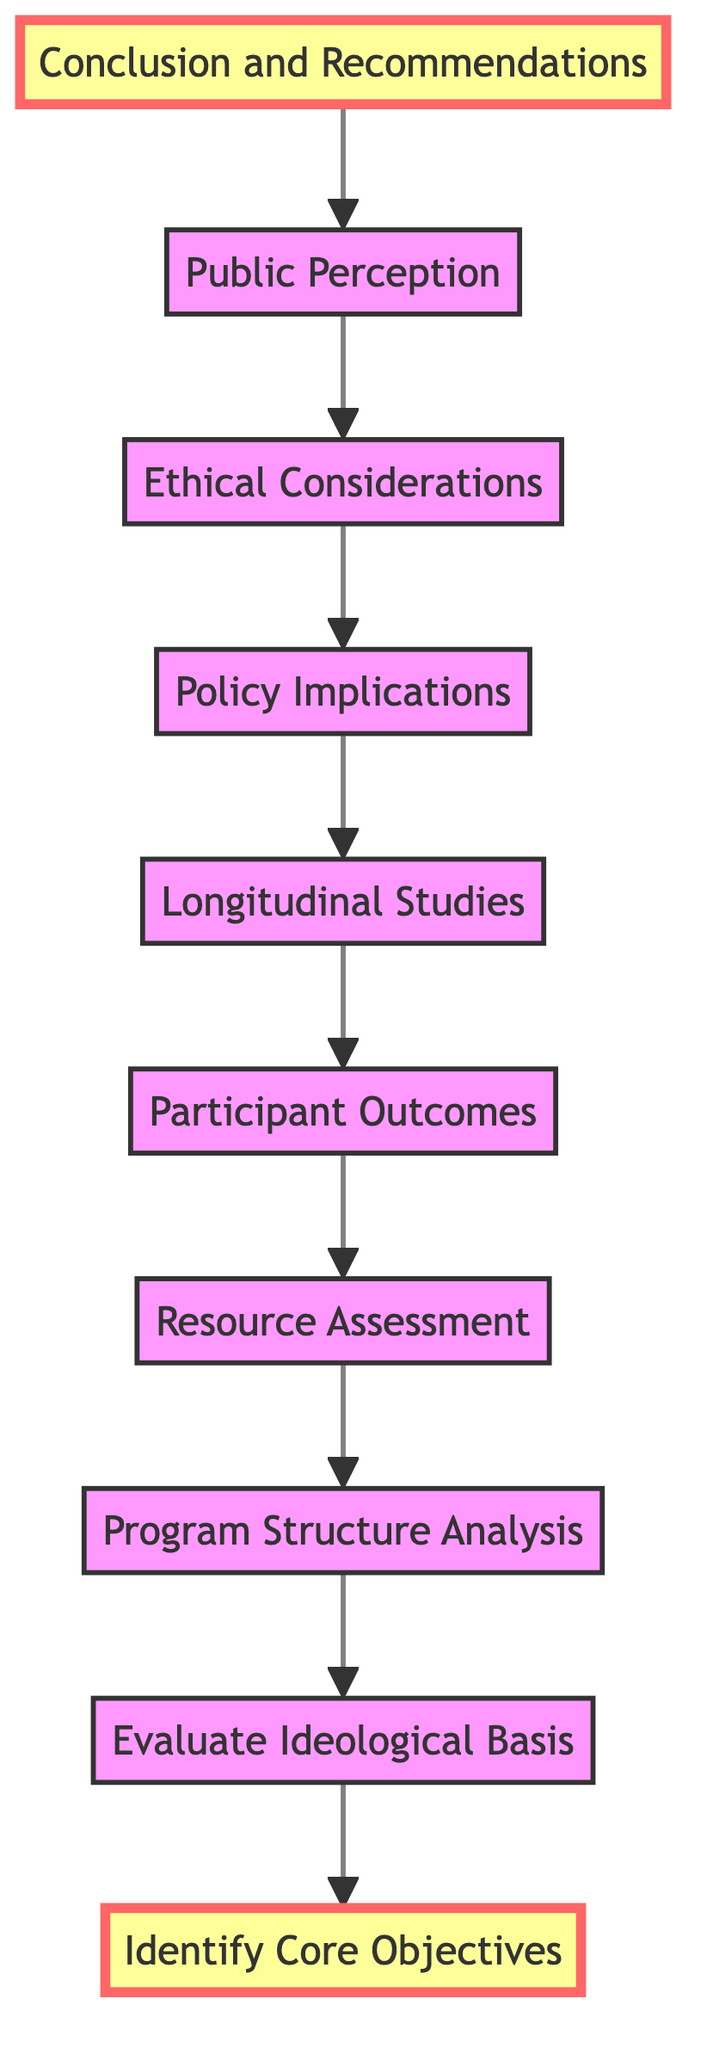What is the first step in the diagram? The first step in the diagram is to identify the core objectives, as it is the bottom-most node in the flow.
Answer: Identify Core Objectives How many nodes are present in the diagram? There are a total of ten nodes represented in the flowchart, each corresponding to a distinct step in the analysis process.
Answer: 10 What is the last step in the flowchart? The last step in the flowchart is to summarize findings and offer recommendations, which is indicated at the top of the diagram.
Answer: Conclusion and Recommendations Which two nodes are directly connected? The nodes "Participant Outcomes" and "Longitudinal Studies" are directly connected, indicating a flow of information from one to the other.
Answer: Participant Outcomes and Longitudinal Studies What type of program is celebrated in the Program Structure Analysis? The Program Structure Analysis focuses on faith-based programs, specifically referring to initiatives like Celebrate Recovery as compared to secular programs.
Answer: Celebrate Recovery Which step comes before the Policy Implications step? The step that comes before the Policy Implications is called Ethical Considerations, as seen in the upward flow of the diagram.
Answer: Ethical Considerations What are the main types of programs compared in this analysis? The main types of programs compared are faith-based programs and secular alternatives, as highlighted in the Evaluation Ideological Basis step.
Answer: Faith-based and secular alternatives Which node directly influences the Resource Assessment? The node that directly influences Resource Assessment is Program Structure Analysis, since the flow moves from one to the other in the diagram.
Answer: Program Structure Analysis What is the purpose of the Longitudinal Studies node? The purpose of the Longitudinal Studies node is to examine long-term data regarding the efficacy and sustainability of rehabilitation programs.
Answer: Examine long-term data What follows the Participant Outcomes in the flow? Following Participant Outcomes in the flow is Resource Assessment, indicating the evaluation of resources used in the programs.
Answer: Resource Assessment 